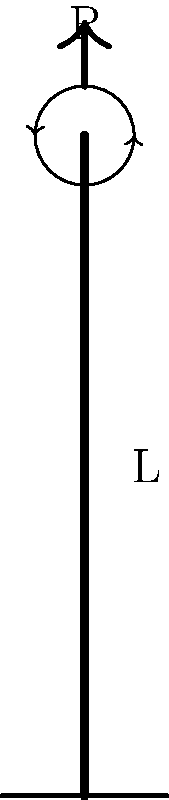As a civil engineer supporting Benjamin Kofi Ayeh's innovative structural designs, you are tasked with analyzing a column in one of his projects. The column has a length L, elastic modulus E, and moment of inertia I. It is fixed at the bottom and free to rotate but not translate at the top, as shown in the figure. Determine the critical buckling load (P_cr) for this column. To determine the critical buckling load for this column, we'll follow these steps:

1) Recognize the end conditions: The column is fixed at the bottom and pinned at the top. This configuration is often referred to as a "fixed-pinned" or "fixed-hinged" column.

2) Recall the general formula for critical buckling load:

   $$P_{cr} = \frac{\pi^2 EI}{(KL)^2}$$

   Where:
   - E is the elastic modulus
   - I is the moment of inertia
   - L is the length of the column
   - K is the effective length factor

3) Determine the effective length factor (K) for this specific end condition:
   For a fixed-pinned column, K = 0.699

4) Substitute this value into the critical buckling load formula:

   $$P_{cr} = \frac{\pi^2 EI}{(0.699L)^2}$$

5) Simplify:

   $$P_{cr} = \frac{\pi^2 EI}{0.488601L^2}$$

6) Further simplification:

   $$P_{cr} \approx \frac{20.19 EI}{L^2}$$

This is the final expression for the critical buckling load for a fixed-pinned column.
Answer: $$P_{cr} \approx \frac{20.19 EI}{L^2}$$ 